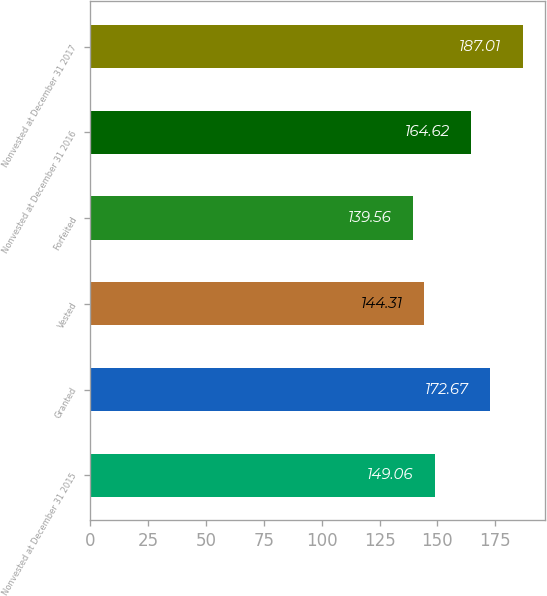Convert chart to OTSL. <chart><loc_0><loc_0><loc_500><loc_500><bar_chart><fcel>Nonvested at December 31 2015<fcel>Granted<fcel>Vested<fcel>Forfeited<fcel>Nonvested at December 31 2016<fcel>Nonvested at December 31 2017<nl><fcel>149.06<fcel>172.67<fcel>144.31<fcel>139.56<fcel>164.62<fcel>187.01<nl></chart> 